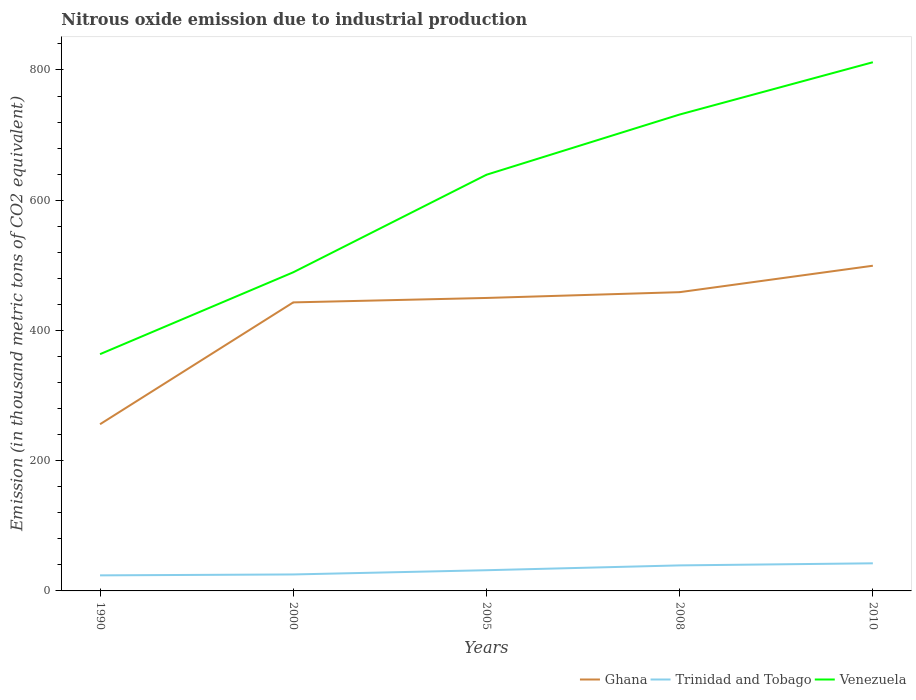Is the number of lines equal to the number of legend labels?
Make the answer very short. Yes. Across all years, what is the maximum amount of nitrous oxide emitted in Ghana?
Offer a very short reply. 256. In which year was the amount of nitrous oxide emitted in Venezuela maximum?
Keep it short and to the point. 1990. What is the total amount of nitrous oxide emitted in Trinidad and Tobago in the graph?
Offer a terse response. -7.9. What is the difference between the highest and the second highest amount of nitrous oxide emitted in Venezuela?
Give a very brief answer. 448.3. How many lines are there?
Offer a terse response. 3. Does the graph contain any zero values?
Offer a terse response. No. Does the graph contain grids?
Keep it short and to the point. No. How many legend labels are there?
Provide a succinct answer. 3. What is the title of the graph?
Your answer should be very brief. Nitrous oxide emission due to industrial production. Does "Papua New Guinea" appear as one of the legend labels in the graph?
Provide a succinct answer. No. What is the label or title of the Y-axis?
Offer a terse response. Emission (in thousand metric tons of CO2 equivalent). What is the Emission (in thousand metric tons of CO2 equivalent) of Ghana in 1990?
Offer a very short reply. 256. What is the Emission (in thousand metric tons of CO2 equivalent) of Trinidad and Tobago in 1990?
Give a very brief answer. 23.9. What is the Emission (in thousand metric tons of CO2 equivalent) in Venezuela in 1990?
Give a very brief answer. 363.6. What is the Emission (in thousand metric tons of CO2 equivalent) of Ghana in 2000?
Provide a succinct answer. 443.1. What is the Emission (in thousand metric tons of CO2 equivalent) in Trinidad and Tobago in 2000?
Your answer should be very brief. 25.3. What is the Emission (in thousand metric tons of CO2 equivalent) in Venezuela in 2000?
Provide a short and direct response. 489.3. What is the Emission (in thousand metric tons of CO2 equivalent) of Ghana in 2005?
Make the answer very short. 449.9. What is the Emission (in thousand metric tons of CO2 equivalent) of Trinidad and Tobago in 2005?
Keep it short and to the point. 31.8. What is the Emission (in thousand metric tons of CO2 equivalent) of Venezuela in 2005?
Provide a short and direct response. 639.1. What is the Emission (in thousand metric tons of CO2 equivalent) of Ghana in 2008?
Your response must be concise. 458.8. What is the Emission (in thousand metric tons of CO2 equivalent) in Trinidad and Tobago in 2008?
Your answer should be compact. 39.2. What is the Emission (in thousand metric tons of CO2 equivalent) in Venezuela in 2008?
Ensure brevity in your answer.  731.6. What is the Emission (in thousand metric tons of CO2 equivalent) in Ghana in 2010?
Ensure brevity in your answer.  499.4. What is the Emission (in thousand metric tons of CO2 equivalent) of Trinidad and Tobago in 2010?
Keep it short and to the point. 42.4. What is the Emission (in thousand metric tons of CO2 equivalent) of Venezuela in 2010?
Your answer should be very brief. 811.9. Across all years, what is the maximum Emission (in thousand metric tons of CO2 equivalent) of Ghana?
Offer a terse response. 499.4. Across all years, what is the maximum Emission (in thousand metric tons of CO2 equivalent) of Trinidad and Tobago?
Provide a succinct answer. 42.4. Across all years, what is the maximum Emission (in thousand metric tons of CO2 equivalent) of Venezuela?
Ensure brevity in your answer.  811.9. Across all years, what is the minimum Emission (in thousand metric tons of CO2 equivalent) of Ghana?
Offer a terse response. 256. Across all years, what is the minimum Emission (in thousand metric tons of CO2 equivalent) in Trinidad and Tobago?
Make the answer very short. 23.9. Across all years, what is the minimum Emission (in thousand metric tons of CO2 equivalent) of Venezuela?
Your response must be concise. 363.6. What is the total Emission (in thousand metric tons of CO2 equivalent) of Ghana in the graph?
Your answer should be very brief. 2107.2. What is the total Emission (in thousand metric tons of CO2 equivalent) in Trinidad and Tobago in the graph?
Provide a succinct answer. 162.6. What is the total Emission (in thousand metric tons of CO2 equivalent) in Venezuela in the graph?
Provide a succinct answer. 3035.5. What is the difference between the Emission (in thousand metric tons of CO2 equivalent) in Ghana in 1990 and that in 2000?
Provide a short and direct response. -187.1. What is the difference between the Emission (in thousand metric tons of CO2 equivalent) in Trinidad and Tobago in 1990 and that in 2000?
Keep it short and to the point. -1.4. What is the difference between the Emission (in thousand metric tons of CO2 equivalent) of Venezuela in 1990 and that in 2000?
Your answer should be very brief. -125.7. What is the difference between the Emission (in thousand metric tons of CO2 equivalent) of Ghana in 1990 and that in 2005?
Your response must be concise. -193.9. What is the difference between the Emission (in thousand metric tons of CO2 equivalent) in Trinidad and Tobago in 1990 and that in 2005?
Your answer should be compact. -7.9. What is the difference between the Emission (in thousand metric tons of CO2 equivalent) in Venezuela in 1990 and that in 2005?
Your response must be concise. -275.5. What is the difference between the Emission (in thousand metric tons of CO2 equivalent) of Ghana in 1990 and that in 2008?
Your answer should be compact. -202.8. What is the difference between the Emission (in thousand metric tons of CO2 equivalent) in Trinidad and Tobago in 1990 and that in 2008?
Give a very brief answer. -15.3. What is the difference between the Emission (in thousand metric tons of CO2 equivalent) in Venezuela in 1990 and that in 2008?
Provide a short and direct response. -368. What is the difference between the Emission (in thousand metric tons of CO2 equivalent) in Ghana in 1990 and that in 2010?
Offer a very short reply. -243.4. What is the difference between the Emission (in thousand metric tons of CO2 equivalent) in Trinidad and Tobago in 1990 and that in 2010?
Make the answer very short. -18.5. What is the difference between the Emission (in thousand metric tons of CO2 equivalent) in Venezuela in 1990 and that in 2010?
Your response must be concise. -448.3. What is the difference between the Emission (in thousand metric tons of CO2 equivalent) of Ghana in 2000 and that in 2005?
Offer a very short reply. -6.8. What is the difference between the Emission (in thousand metric tons of CO2 equivalent) of Venezuela in 2000 and that in 2005?
Provide a short and direct response. -149.8. What is the difference between the Emission (in thousand metric tons of CO2 equivalent) in Ghana in 2000 and that in 2008?
Offer a terse response. -15.7. What is the difference between the Emission (in thousand metric tons of CO2 equivalent) in Trinidad and Tobago in 2000 and that in 2008?
Provide a succinct answer. -13.9. What is the difference between the Emission (in thousand metric tons of CO2 equivalent) in Venezuela in 2000 and that in 2008?
Make the answer very short. -242.3. What is the difference between the Emission (in thousand metric tons of CO2 equivalent) of Ghana in 2000 and that in 2010?
Make the answer very short. -56.3. What is the difference between the Emission (in thousand metric tons of CO2 equivalent) in Trinidad and Tobago in 2000 and that in 2010?
Your answer should be very brief. -17.1. What is the difference between the Emission (in thousand metric tons of CO2 equivalent) in Venezuela in 2000 and that in 2010?
Your answer should be compact. -322.6. What is the difference between the Emission (in thousand metric tons of CO2 equivalent) of Ghana in 2005 and that in 2008?
Your answer should be very brief. -8.9. What is the difference between the Emission (in thousand metric tons of CO2 equivalent) of Trinidad and Tobago in 2005 and that in 2008?
Your answer should be very brief. -7.4. What is the difference between the Emission (in thousand metric tons of CO2 equivalent) of Venezuela in 2005 and that in 2008?
Provide a succinct answer. -92.5. What is the difference between the Emission (in thousand metric tons of CO2 equivalent) in Ghana in 2005 and that in 2010?
Give a very brief answer. -49.5. What is the difference between the Emission (in thousand metric tons of CO2 equivalent) in Venezuela in 2005 and that in 2010?
Ensure brevity in your answer.  -172.8. What is the difference between the Emission (in thousand metric tons of CO2 equivalent) of Ghana in 2008 and that in 2010?
Your answer should be compact. -40.6. What is the difference between the Emission (in thousand metric tons of CO2 equivalent) in Trinidad and Tobago in 2008 and that in 2010?
Provide a succinct answer. -3.2. What is the difference between the Emission (in thousand metric tons of CO2 equivalent) in Venezuela in 2008 and that in 2010?
Keep it short and to the point. -80.3. What is the difference between the Emission (in thousand metric tons of CO2 equivalent) in Ghana in 1990 and the Emission (in thousand metric tons of CO2 equivalent) in Trinidad and Tobago in 2000?
Offer a terse response. 230.7. What is the difference between the Emission (in thousand metric tons of CO2 equivalent) of Ghana in 1990 and the Emission (in thousand metric tons of CO2 equivalent) of Venezuela in 2000?
Give a very brief answer. -233.3. What is the difference between the Emission (in thousand metric tons of CO2 equivalent) in Trinidad and Tobago in 1990 and the Emission (in thousand metric tons of CO2 equivalent) in Venezuela in 2000?
Offer a very short reply. -465.4. What is the difference between the Emission (in thousand metric tons of CO2 equivalent) in Ghana in 1990 and the Emission (in thousand metric tons of CO2 equivalent) in Trinidad and Tobago in 2005?
Make the answer very short. 224.2. What is the difference between the Emission (in thousand metric tons of CO2 equivalent) in Ghana in 1990 and the Emission (in thousand metric tons of CO2 equivalent) in Venezuela in 2005?
Make the answer very short. -383.1. What is the difference between the Emission (in thousand metric tons of CO2 equivalent) of Trinidad and Tobago in 1990 and the Emission (in thousand metric tons of CO2 equivalent) of Venezuela in 2005?
Keep it short and to the point. -615.2. What is the difference between the Emission (in thousand metric tons of CO2 equivalent) of Ghana in 1990 and the Emission (in thousand metric tons of CO2 equivalent) of Trinidad and Tobago in 2008?
Provide a succinct answer. 216.8. What is the difference between the Emission (in thousand metric tons of CO2 equivalent) in Ghana in 1990 and the Emission (in thousand metric tons of CO2 equivalent) in Venezuela in 2008?
Your answer should be compact. -475.6. What is the difference between the Emission (in thousand metric tons of CO2 equivalent) in Trinidad and Tobago in 1990 and the Emission (in thousand metric tons of CO2 equivalent) in Venezuela in 2008?
Keep it short and to the point. -707.7. What is the difference between the Emission (in thousand metric tons of CO2 equivalent) in Ghana in 1990 and the Emission (in thousand metric tons of CO2 equivalent) in Trinidad and Tobago in 2010?
Provide a succinct answer. 213.6. What is the difference between the Emission (in thousand metric tons of CO2 equivalent) in Ghana in 1990 and the Emission (in thousand metric tons of CO2 equivalent) in Venezuela in 2010?
Provide a short and direct response. -555.9. What is the difference between the Emission (in thousand metric tons of CO2 equivalent) of Trinidad and Tobago in 1990 and the Emission (in thousand metric tons of CO2 equivalent) of Venezuela in 2010?
Provide a short and direct response. -788. What is the difference between the Emission (in thousand metric tons of CO2 equivalent) in Ghana in 2000 and the Emission (in thousand metric tons of CO2 equivalent) in Trinidad and Tobago in 2005?
Provide a short and direct response. 411.3. What is the difference between the Emission (in thousand metric tons of CO2 equivalent) of Ghana in 2000 and the Emission (in thousand metric tons of CO2 equivalent) of Venezuela in 2005?
Provide a succinct answer. -196. What is the difference between the Emission (in thousand metric tons of CO2 equivalent) of Trinidad and Tobago in 2000 and the Emission (in thousand metric tons of CO2 equivalent) of Venezuela in 2005?
Your response must be concise. -613.8. What is the difference between the Emission (in thousand metric tons of CO2 equivalent) in Ghana in 2000 and the Emission (in thousand metric tons of CO2 equivalent) in Trinidad and Tobago in 2008?
Make the answer very short. 403.9. What is the difference between the Emission (in thousand metric tons of CO2 equivalent) in Ghana in 2000 and the Emission (in thousand metric tons of CO2 equivalent) in Venezuela in 2008?
Make the answer very short. -288.5. What is the difference between the Emission (in thousand metric tons of CO2 equivalent) of Trinidad and Tobago in 2000 and the Emission (in thousand metric tons of CO2 equivalent) of Venezuela in 2008?
Offer a terse response. -706.3. What is the difference between the Emission (in thousand metric tons of CO2 equivalent) of Ghana in 2000 and the Emission (in thousand metric tons of CO2 equivalent) of Trinidad and Tobago in 2010?
Provide a succinct answer. 400.7. What is the difference between the Emission (in thousand metric tons of CO2 equivalent) of Ghana in 2000 and the Emission (in thousand metric tons of CO2 equivalent) of Venezuela in 2010?
Your response must be concise. -368.8. What is the difference between the Emission (in thousand metric tons of CO2 equivalent) of Trinidad and Tobago in 2000 and the Emission (in thousand metric tons of CO2 equivalent) of Venezuela in 2010?
Your answer should be compact. -786.6. What is the difference between the Emission (in thousand metric tons of CO2 equivalent) of Ghana in 2005 and the Emission (in thousand metric tons of CO2 equivalent) of Trinidad and Tobago in 2008?
Your answer should be compact. 410.7. What is the difference between the Emission (in thousand metric tons of CO2 equivalent) in Ghana in 2005 and the Emission (in thousand metric tons of CO2 equivalent) in Venezuela in 2008?
Give a very brief answer. -281.7. What is the difference between the Emission (in thousand metric tons of CO2 equivalent) of Trinidad and Tobago in 2005 and the Emission (in thousand metric tons of CO2 equivalent) of Venezuela in 2008?
Give a very brief answer. -699.8. What is the difference between the Emission (in thousand metric tons of CO2 equivalent) in Ghana in 2005 and the Emission (in thousand metric tons of CO2 equivalent) in Trinidad and Tobago in 2010?
Your answer should be very brief. 407.5. What is the difference between the Emission (in thousand metric tons of CO2 equivalent) of Ghana in 2005 and the Emission (in thousand metric tons of CO2 equivalent) of Venezuela in 2010?
Your answer should be compact. -362. What is the difference between the Emission (in thousand metric tons of CO2 equivalent) of Trinidad and Tobago in 2005 and the Emission (in thousand metric tons of CO2 equivalent) of Venezuela in 2010?
Ensure brevity in your answer.  -780.1. What is the difference between the Emission (in thousand metric tons of CO2 equivalent) in Ghana in 2008 and the Emission (in thousand metric tons of CO2 equivalent) in Trinidad and Tobago in 2010?
Your response must be concise. 416.4. What is the difference between the Emission (in thousand metric tons of CO2 equivalent) of Ghana in 2008 and the Emission (in thousand metric tons of CO2 equivalent) of Venezuela in 2010?
Provide a succinct answer. -353.1. What is the difference between the Emission (in thousand metric tons of CO2 equivalent) in Trinidad and Tobago in 2008 and the Emission (in thousand metric tons of CO2 equivalent) in Venezuela in 2010?
Make the answer very short. -772.7. What is the average Emission (in thousand metric tons of CO2 equivalent) of Ghana per year?
Provide a short and direct response. 421.44. What is the average Emission (in thousand metric tons of CO2 equivalent) of Trinidad and Tobago per year?
Make the answer very short. 32.52. What is the average Emission (in thousand metric tons of CO2 equivalent) in Venezuela per year?
Offer a terse response. 607.1. In the year 1990, what is the difference between the Emission (in thousand metric tons of CO2 equivalent) of Ghana and Emission (in thousand metric tons of CO2 equivalent) of Trinidad and Tobago?
Ensure brevity in your answer.  232.1. In the year 1990, what is the difference between the Emission (in thousand metric tons of CO2 equivalent) in Ghana and Emission (in thousand metric tons of CO2 equivalent) in Venezuela?
Make the answer very short. -107.6. In the year 1990, what is the difference between the Emission (in thousand metric tons of CO2 equivalent) in Trinidad and Tobago and Emission (in thousand metric tons of CO2 equivalent) in Venezuela?
Make the answer very short. -339.7. In the year 2000, what is the difference between the Emission (in thousand metric tons of CO2 equivalent) in Ghana and Emission (in thousand metric tons of CO2 equivalent) in Trinidad and Tobago?
Your response must be concise. 417.8. In the year 2000, what is the difference between the Emission (in thousand metric tons of CO2 equivalent) in Ghana and Emission (in thousand metric tons of CO2 equivalent) in Venezuela?
Ensure brevity in your answer.  -46.2. In the year 2000, what is the difference between the Emission (in thousand metric tons of CO2 equivalent) of Trinidad and Tobago and Emission (in thousand metric tons of CO2 equivalent) of Venezuela?
Your answer should be very brief. -464. In the year 2005, what is the difference between the Emission (in thousand metric tons of CO2 equivalent) of Ghana and Emission (in thousand metric tons of CO2 equivalent) of Trinidad and Tobago?
Offer a very short reply. 418.1. In the year 2005, what is the difference between the Emission (in thousand metric tons of CO2 equivalent) of Ghana and Emission (in thousand metric tons of CO2 equivalent) of Venezuela?
Your answer should be very brief. -189.2. In the year 2005, what is the difference between the Emission (in thousand metric tons of CO2 equivalent) in Trinidad and Tobago and Emission (in thousand metric tons of CO2 equivalent) in Venezuela?
Give a very brief answer. -607.3. In the year 2008, what is the difference between the Emission (in thousand metric tons of CO2 equivalent) of Ghana and Emission (in thousand metric tons of CO2 equivalent) of Trinidad and Tobago?
Your answer should be compact. 419.6. In the year 2008, what is the difference between the Emission (in thousand metric tons of CO2 equivalent) in Ghana and Emission (in thousand metric tons of CO2 equivalent) in Venezuela?
Offer a very short reply. -272.8. In the year 2008, what is the difference between the Emission (in thousand metric tons of CO2 equivalent) in Trinidad and Tobago and Emission (in thousand metric tons of CO2 equivalent) in Venezuela?
Offer a terse response. -692.4. In the year 2010, what is the difference between the Emission (in thousand metric tons of CO2 equivalent) in Ghana and Emission (in thousand metric tons of CO2 equivalent) in Trinidad and Tobago?
Offer a very short reply. 457. In the year 2010, what is the difference between the Emission (in thousand metric tons of CO2 equivalent) in Ghana and Emission (in thousand metric tons of CO2 equivalent) in Venezuela?
Make the answer very short. -312.5. In the year 2010, what is the difference between the Emission (in thousand metric tons of CO2 equivalent) in Trinidad and Tobago and Emission (in thousand metric tons of CO2 equivalent) in Venezuela?
Offer a very short reply. -769.5. What is the ratio of the Emission (in thousand metric tons of CO2 equivalent) of Ghana in 1990 to that in 2000?
Offer a terse response. 0.58. What is the ratio of the Emission (in thousand metric tons of CO2 equivalent) in Trinidad and Tobago in 1990 to that in 2000?
Offer a terse response. 0.94. What is the ratio of the Emission (in thousand metric tons of CO2 equivalent) in Venezuela in 1990 to that in 2000?
Your answer should be compact. 0.74. What is the ratio of the Emission (in thousand metric tons of CO2 equivalent) of Ghana in 1990 to that in 2005?
Offer a terse response. 0.57. What is the ratio of the Emission (in thousand metric tons of CO2 equivalent) in Trinidad and Tobago in 1990 to that in 2005?
Make the answer very short. 0.75. What is the ratio of the Emission (in thousand metric tons of CO2 equivalent) in Venezuela in 1990 to that in 2005?
Keep it short and to the point. 0.57. What is the ratio of the Emission (in thousand metric tons of CO2 equivalent) in Ghana in 1990 to that in 2008?
Your answer should be compact. 0.56. What is the ratio of the Emission (in thousand metric tons of CO2 equivalent) in Trinidad and Tobago in 1990 to that in 2008?
Give a very brief answer. 0.61. What is the ratio of the Emission (in thousand metric tons of CO2 equivalent) of Venezuela in 1990 to that in 2008?
Offer a very short reply. 0.5. What is the ratio of the Emission (in thousand metric tons of CO2 equivalent) in Ghana in 1990 to that in 2010?
Provide a succinct answer. 0.51. What is the ratio of the Emission (in thousand metric tons of CO2 equivalent) of Trinidad and Tobago in 1990 to that in 2010?
Keep it short and to the point. 0.56. What is the ratio of the Emission (in thousand metric tons of CO2 equivalent) of Venezuela in 1990 to that in 2010?
Ensure brevity in your answer.  0.45. What is the ratio of the Emission (in thousand metric tons of CO2 equivalent) in Ghana in 2000 to that in 2005?
Your answer should be very brief. 0.98. What is the ratio of the Emission (in thousand metric tons of CO2 equivalent) in Trinidad and Tobago in 2000 to that in 2005?
Make the answer very short. 0.8. What is the ratio of the Emission (in thousand metric tons of CO2 equivalent) in Venezuela in 2000 to that in 2005?
Offer a terse response. 0.77. What is the ratio of the Emission (in thousand metric tons of CO2 equivalent) of Ghana in 2000 to that in 2008?
Keep it short and to the point. 0.97. What is the ratio of the Emission (in thousand metric tons of CO2 equivalent) of Trinidad and Tobago in 2000 to that in 2008?
Make the answer very short. 0.65. What is the ratio of the Emission (in thousand metric tons of CO2 equivalent) in Venezuela in 2000 to that in 2008?
Your response must be concise. 0.67. What is the ratio of the Emission (in thousand metric tons of CO2 equivalent) of Ghana in 2000 to that in 2010?
Offer a very short reply. 0.89. What is the ratio of the Emission (in thousand metric tons of CO2 equivalent) of Trinidad and Tobago in 2000 to that in 2010?
Ensure brevity in your answer.  0.6. What is the ratio of the Emission (in thousand metric tons of CO2 equivalent) in Venezuela in 2000 to that in 2010?
Keep it short and to the point. 0.6. What is the ratio of the Emission (in thousand metric tons of CO2 equivalent) of Ghana in 2005 to that in 2008?
Your answer should be compact. 0.98. What is the ratio of the Emission (in thousand metric tons of CO2 equivalent) in Trinidad and Tobago in 2005 to that in 2008?
Keep it short and to the point. 0.81. What is the ratio of the Emission (in thousand metric tons of CO2 equivalent) of Venezuela in 2005 to that in 2008?
Your answer should be very brief. 0.87. What is the ratio of the Emission (in thousand metric tons of CO2 equivalent) of Ghana in 2005 to that in 2010?
Offer a very short reply. 0.9. What is the ratio of the Emission (in thousand metric tons of CO2 equivalent) in Trinidad and Tobago in 2005 to that in 2010?
Offer a terse response. 0.75. What is the ratio of the Emission (in thousand metric tons of CO2 equivalent) of Venezuela in 2005 to that in 2010?
Ensure brevity in your answer.  0.79. What is the ratio of the Emission (in thousand metric tons of CO2 equivalent) of Ghana in 2008 to that in 2010?
Your answer should be very brief. 0.92. What is the ratio of the Emission (in thousand metric tons of CO2 equivalent) of Trinidad and Tobago in 2008 to that in 2010?
Your answer should be very brief. 0.92. What is the ratio of the Emission (in thousand metric tons of CO2 equivalent) of Venezuela in 2008 to that in 2010?
Your response must be concise. 0.9. What is the difference between the highest and the second highest Emission (in thousand metric tons of CO2 equivalent) in Ghana?
Offer a very short reply. 40.6. What is the difference between the highest and the second highest Emission (in thousand metric tons of CO2 equivalent) in Trinidad and Tobago?
Ensure brevity in your answer.  3.2. What is the difference between the highest and the second highest Emission (in thousand metric tons of CO2 equivalent) in Venezuela?
Make the answer very short. 80.3. What is the difference between the highest and the lowest Emission (in thousand metric tons of CO2 equivalent) of Ghana?
Provide a short and direct response. 243.4. What is the difference between the highest and the lowest Emission (in thousand metric tons of CO2 equivalent) in Venezuela?
Provide a succinct answer. 448.3. 